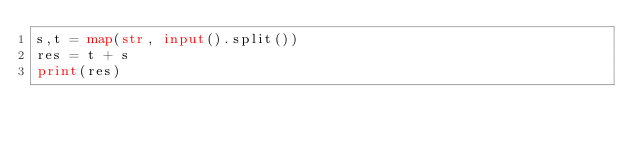<code> <loc_0><loc_0><loc_500><loc_500><_Python_>s,t = map(str, input().split())
res = t + s
print(res)</code> 